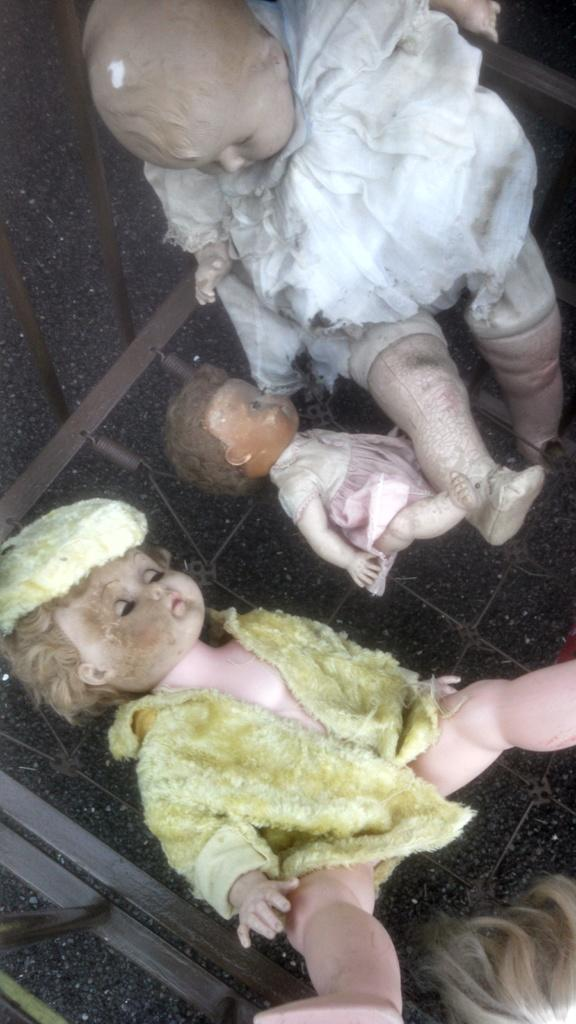What type of objects can be seen in the image? There are dolls and metal poles in the image. Can you describe the dolls in the image? The facts provided do not give specific details about the dolls, but we know they are present in the image. What can you tell me about the metal poles in the image? The facts provided do not give specific details about the metal poles, but we know they are present in the image. Where is the pig located in the image? There is no pig present in the image. What type of toothbrush is being used by the dolls in the image? There is no toothbrush present in the image. 